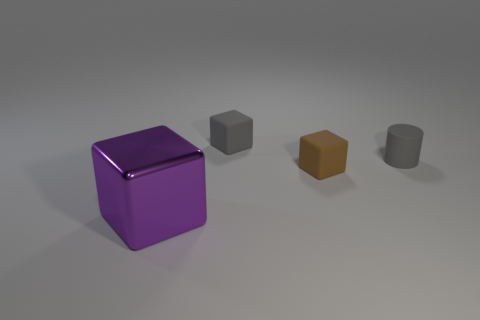Subtract all tiny rubber cubes. How many cubes are left? 1 Subtract 1 blocks. How many blocks are left? 2 Subtract all yellow cylinders. Subtract all yellow spheres. How many cylinders are left? 1 Subtract all blue spheres. How many brown cubes are left? 1 Subtract all red rubber spheres. Subtract all shiny blocks. How many objects are left? 3 Add 3 rubber cylinders. How many rubber cylinders are left? 4 Add 4 cyan rubber objects. How many cyan rubber objects exist? 4 Add 3 purple shiny blocks. How many objects exist? 7 Subtract all brown cubes. How many cubes are left? 2 Subtract 0 yellow blocks. How many objects are left? 4 